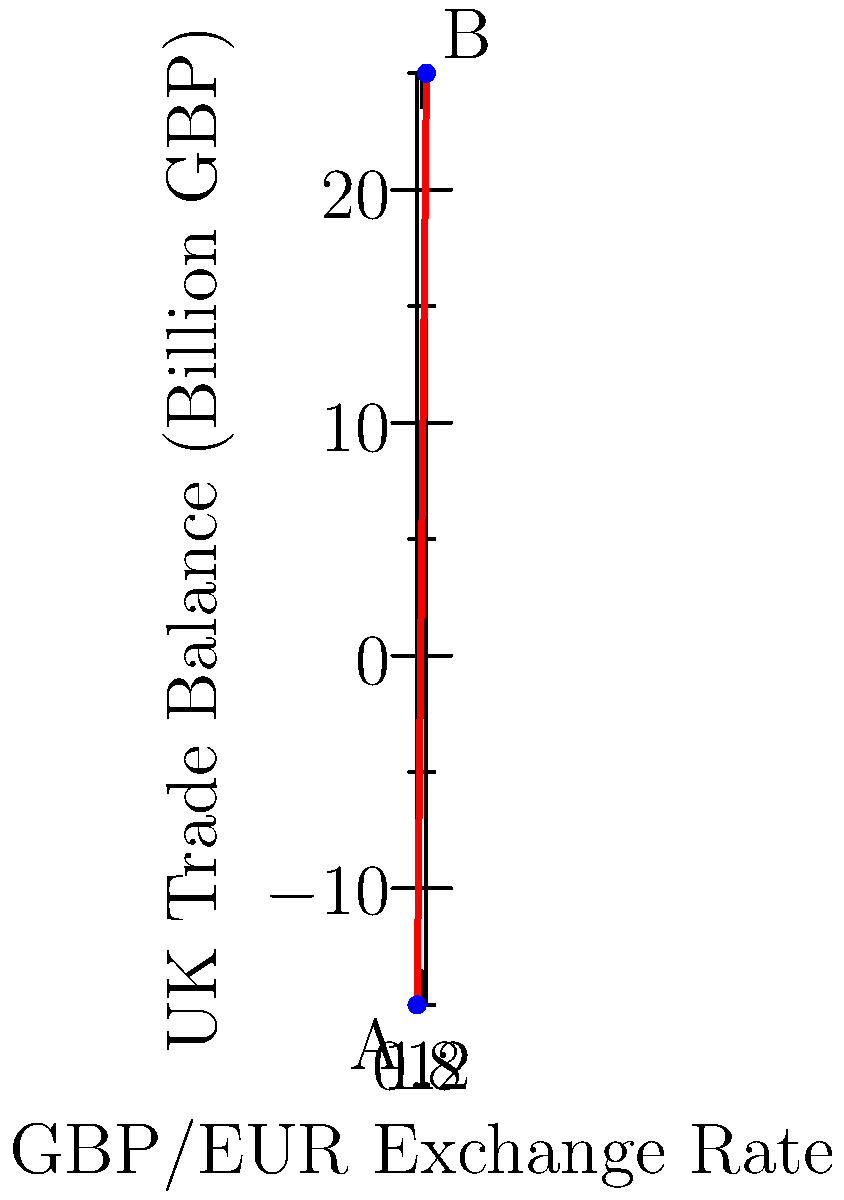The scatter plot shows the relationship between the GBP/EUR exchange rate and the UK trade balance. As a trade policy advisor, how would you interpret the trend, and what implications does this have for British exports to the Eurozone when the exchange rate moves from point A to point B? To interpret the trend and its implications, let's follow these steps:

1. Observe the trend: The scatter plot shows a positive correlation between the GBP/EUR exchange rate and the UK trade balance.

2. Interpret the exchange rate:
   - At point A: GBP/EUR ≈ 0.8, meaning 1 EUR = 1.25 GBP
   - At point B: GBP/EUR ≈ 1.2, meaning 1 EUR = 0.83 GBP

3. Analyze the change:
   - Moving from A to B represents a strengthening of the GBP against the EUR.
   - The pound becomes more valuable relative to the euro.

4. Impact on exports:
   - A stronger pound makes British goods more expensive for Eurozone buyers.
   - The price of British exports in euros increases.

5. Effect on trade balance:
   - Despite the currency appreciation, the trade balance improves.
   - This suggests other factors are at play, such as:
     a) Increased demand for high-value British goods or services
     b) Improved competitiveness in non-price factors (e.g., quality, innovation)
     c) Possible decrease in imports or changes in other trading relationships

6. Implications for British exports to the Eurozone:
   - The volume of exports might decrease due to higher prices.
   - However, the value of exports in GBP could increase.
   - British exporters may need to focus on quality and uniqueness to justify higher prices.
   - They might also need to explore cost-cutting measures to remain competitive.

7. Policy considerations:
   - Monitor the impact on different sectors of the economy.
   - Consider support for industries heavily reliant on exports to the Eurozone.
   - Explore opportunities in markets where the stronger pound provides advantages (e.g., for imports or investment).
Answer: The strengthening GBP may reduce export volume but increase value. Exporters should focus on quality and efficiency to remain competitive in the Eurozone market. 